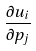<formula> <loc_0><loc_0><loc_500><loc_500>\frac { \partial u _ { i } } { \partial p _ { j } }</formula> 